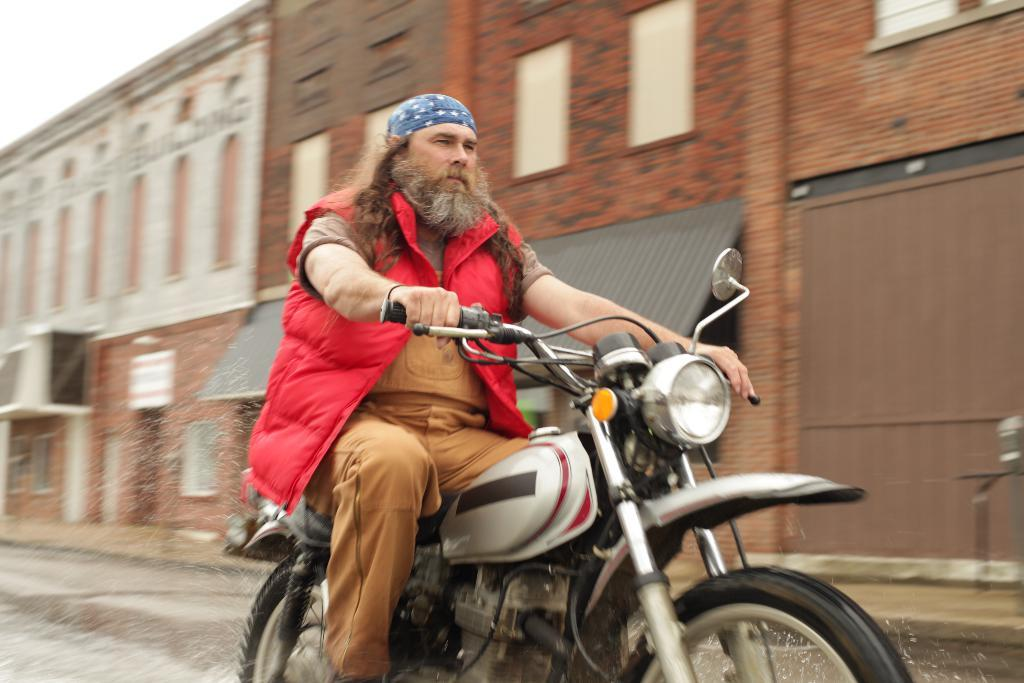Who is the main subject in the image? There is a man in the image. What is the man doing in the image? The man is riding a two-wheeler. What can be seen in the background of the image? There is a building in the background of the image. How is the weather in the image? The sky is clear in the image, suggesting good weather. What type of quarter is the man holding while riding the two-wheeler in the image? There is no quarter present in the image, and the man is not holding anything while riding the two-wheeler. Can you see the tail of the animal accompanying the man in the image? There is no animal present in the image, so there is no tail to be seen. 